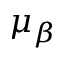<formula> <loc_0><loc_0><loc_500><loc_500>\mu _ { \beta }</formula> 